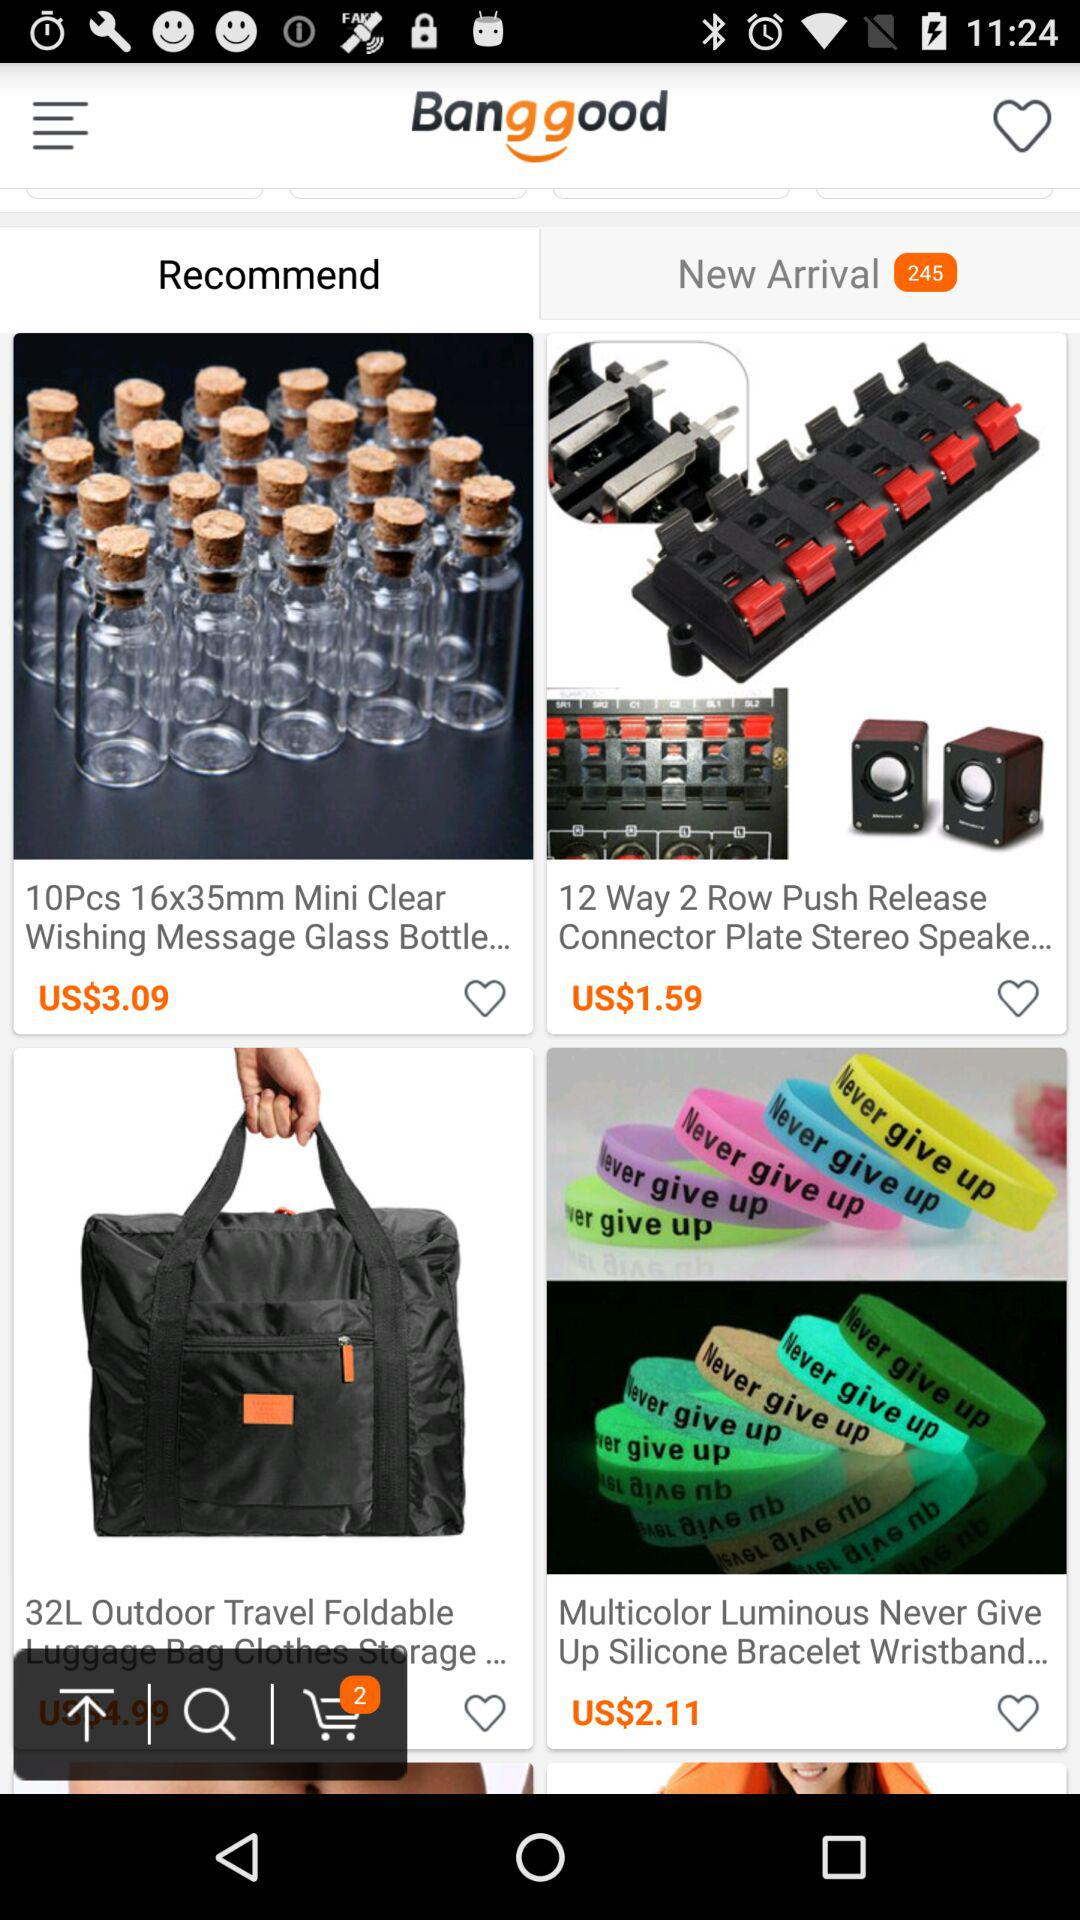How many products are in the cart? There are 2 products in the cart. 